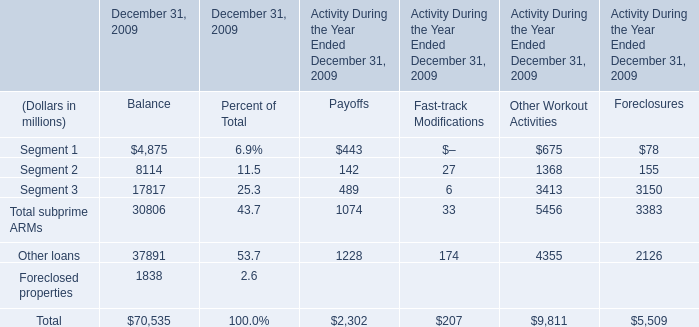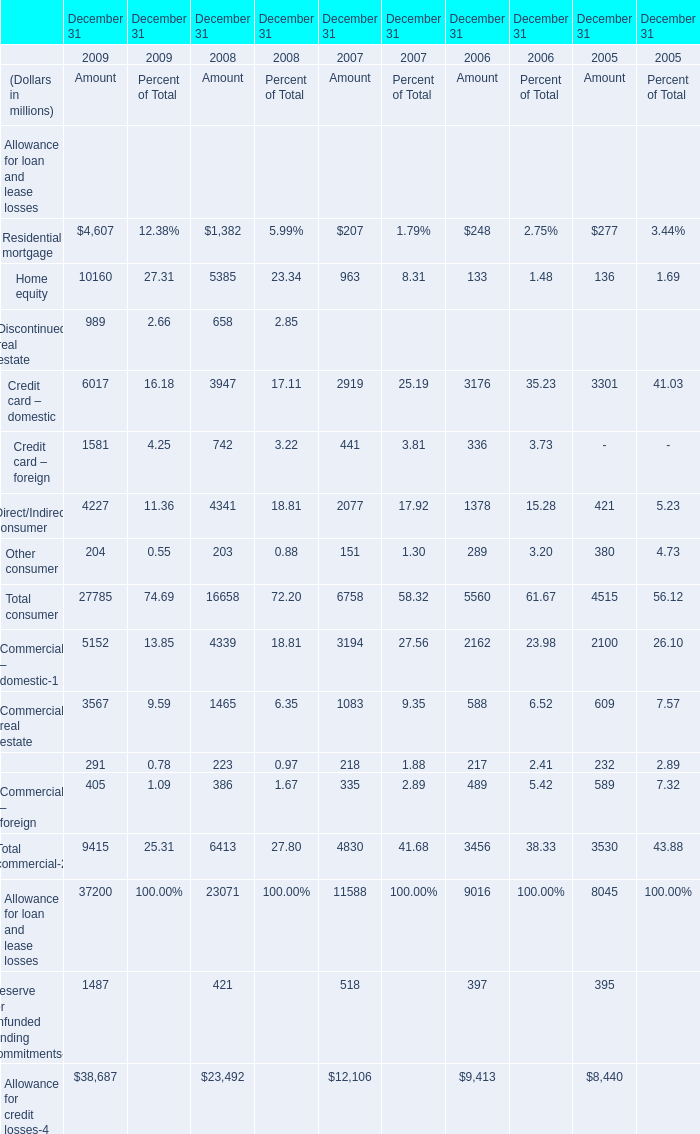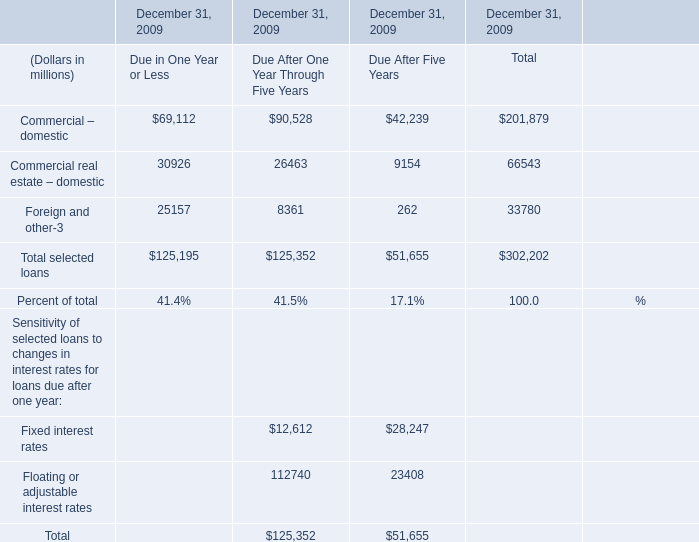How many Fixed interest rates are greater than 20000 in 2009? 
Answer: 1. 